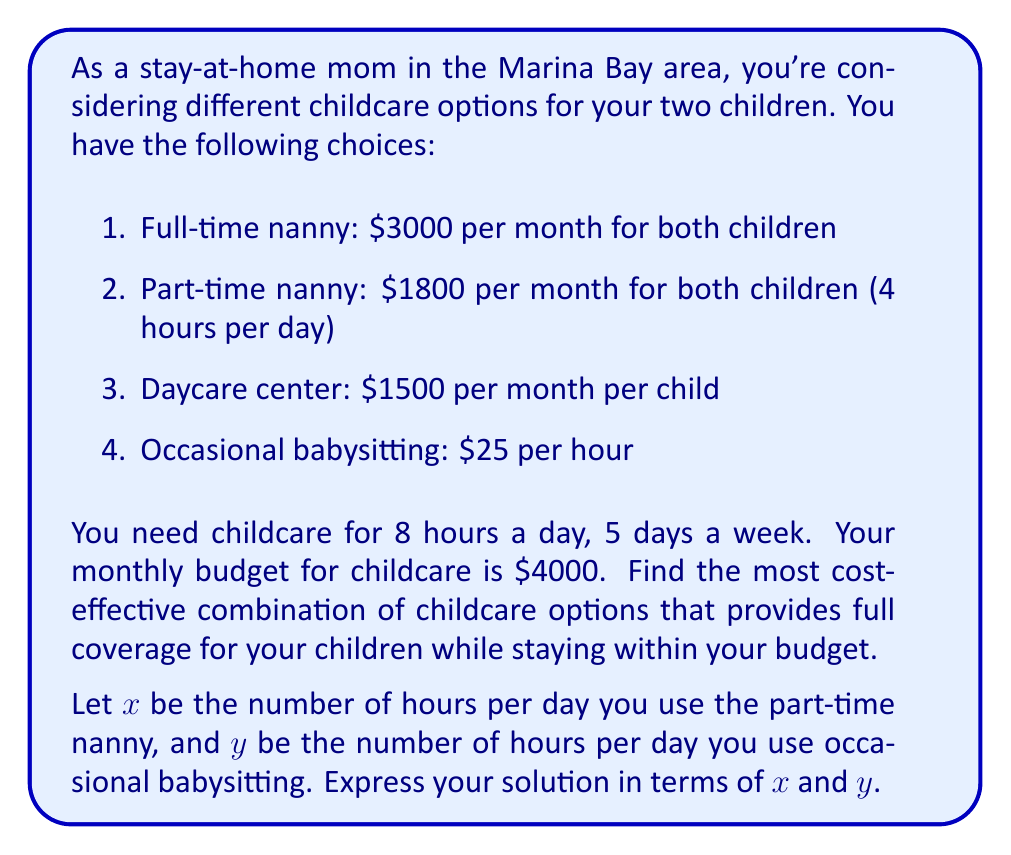Show me your answer to this math problem. Let's approach this problem step by step:

1) First, we need to set up our constraints:

   a) Total hours of care needed: 8 hours per day
      $$x + y = 8$$

   b) Budget constraint: The total cost must not exceed $4000 per month
      Let's convert all costs to monthly rates (assuming 22 working days per month):
      - Part-time nanny: $1800 per month for 4 hours per day
      - Occasional babysitting: $25 * 22 = $550 per month for 1 hour per day

2) Now, let's set up our cost function:

   Monthly cost = Cost of part-time nanny + Cost of babysitting
   $$C(x,y) = 1800 * \frac{x}{4} + 550y$$

3) Our objective is to minimize this cost function subject to our constraints:

   Minimize: $$C(x,y) = 450x + 550y$$
   Subject to: $$x + y = 8$$ and $$450x + 550y \leq 4000$$

4) We can solve this using the substitution method:
   Substitute $y = 8 - x$ into the cost function:

   $$C(x) = 450x + 550(8-x) = 450x + 4400 - 550x = 4400 - 100x$$

5) This shows that the cost decreases as $x$ increases. Therefore, we should maximize $x$ within our constraints.

6) From the budget constraint:
   $$450x + 550(8-x) \leq 4000$$
   $$450x + 4400 - 550x \leq 4000$$
   $$4400 - 100x \leq 4000$$
   $$-100x \leq -400$$
   $$x \geq 4$$

7) Therefore, the optimal solution is to use the part-time nanny for 4 hours per day (which is the maximum available) and use babysitting for the remaining 4 hours.
Answer: The most cost-effective combination is:
- Use the part-time nanny for $x = 4$ hours per day
- Use occasional babysitting for $y = 4$ hours per day

Total monthly cost: $C(4,4) = 450(4) + 550(4) = 1800 + 2200 = $4000 